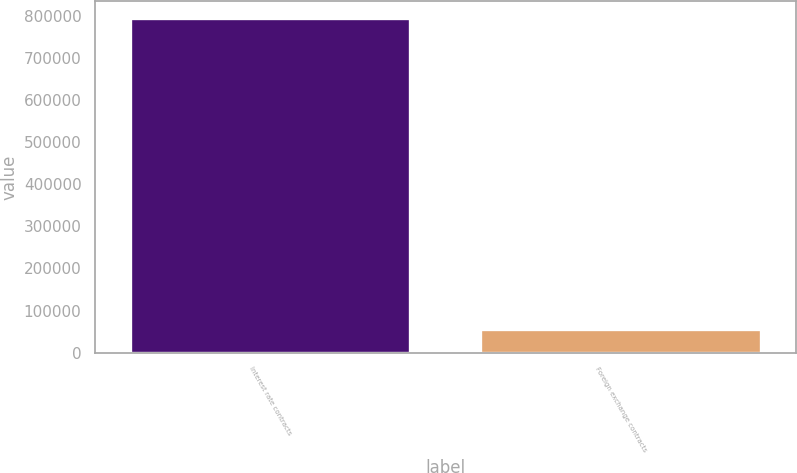<chart> <loc_0><loc_0><loc_500><loc_500><bar_chart><fcel>Interest rate contracts<fcel>Foreign exchange contracts<nl><fcel>793936<fcel>56094<nl></chart> 